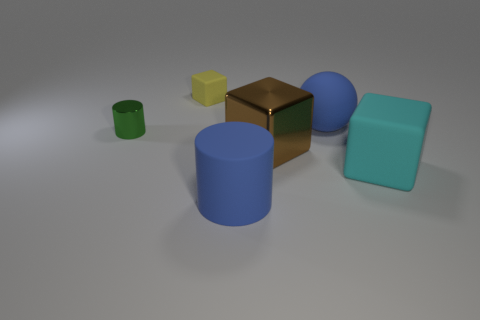Can you describe the lighting and shadows in the scene? The lighting in the scene is soft and diffused, coming from the upper left-hand side, which is casting gentle shadows to the right of the objects, indicating a single light source. 